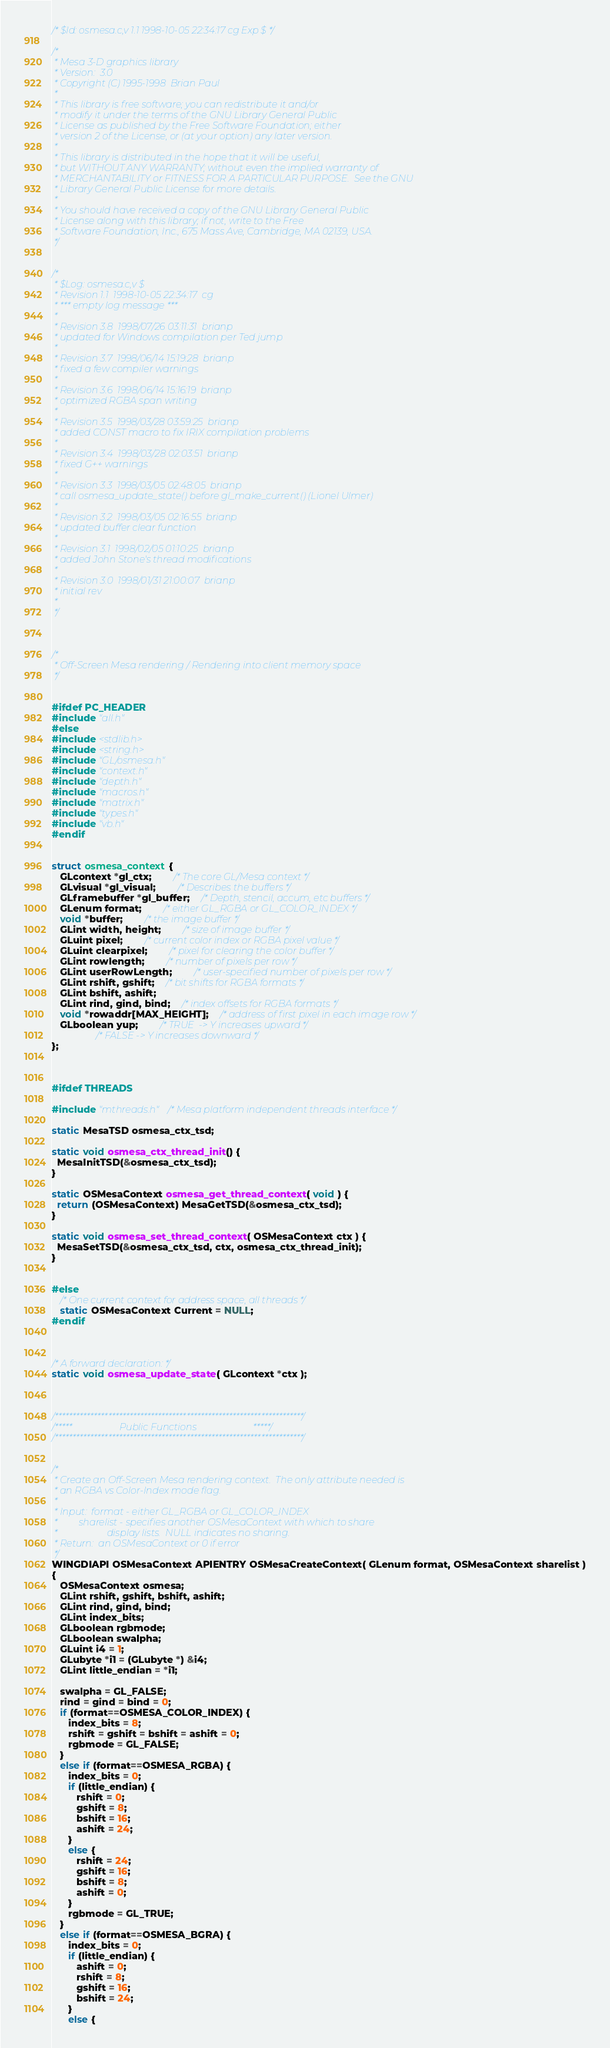<code> <loc_0><loc_0><loc_500><loc_500><_C_>/* $Id: osmesa.c,v 1.1 1998-10-05 22:34:17 cg Exp $ */

/*
 * Mesa 3-D graphics library
 * Version:  3.0
 * Copyright (C) 1995-1998  Brian Paul
 *
 * This library is free software; you can redistribute it and/or
 * modify it under the terms of the GNU Library General Public
 * License as published by the Free Software Foundation; either
 * version 2 of the License, or (at your option) any later version.
 *
 * This library is distributed in the hope that it will be useful,
 * but WITHOUT ANY WARRANTY; without even the implied warranty of
 * MERCHANTABILITY or FITNESS FOR A PARTICULAR PURPOSE.  See the GNU
 * Library General Public License for more details.
 *
 * You should have received a copy of the GNU Library General Public
 * License along with this library; if not, write to the Free
 * Software Foundation, Inc., 675 Mass Ave, Cambridge, MA 02139, USA.
 */


/*
 * $Log: osmesa.c,v $
 * Revision 1.1  1998-10-05 22:34:17  cg
 * *** empty log message ***
 *
 * Revision 3.8  1998/07/26 03:11:31  brianp
 * updated for Windows compilation per Ted jump
 *
 * Revision 3.7  1998/06/14 15:19:28  brianp
 * fixed a few compiler warnings
 *
 * Revision 3.6  1998/06/14 15:16:19  brianp
 * optimized RGBA span writing
 *
 * Revision 3.5  1998/03/28 03:59:25  brianp
 * added CONST macro to fix IRIX compilation problems
 *
 * Revision 3.4  1998/03/28 02:03:51  brianp
 * fixed G++ warnings
 *
 * Revision 3.3  1998/03/05 02:48:05  brianp
 * call osmesa_update_state() before gl_make_current() (Lionel Ulmer)
 *
 * Revision 3.2  1998/03/05 02:16:55  brianp
 * updated buffer clear function
 *
 * Revision 3.1  1998/02/05 01:10:25  brianp
 * added John Stone's thread modifications
 *
 * Revision 3.0  1998/01/31 21:00:07  brianp
 * initial rev
 *
 */



/*
 * Off-Screen Mesa rendering / Rendering into client memory space
 */


#ifdef PC_HEADER
#include "all.h"
#else
#include <stdlib.h>
#include <string.h>
#include "GL/osmesa.h"
#include "context.h"
#include "depth.h"
#include "macros.h"
#include "matrix.h"
#include "types.h"
#include "vb.h"
#endif


struct osmesa_context {
   GLcontext *gl_ctx;		/* The core GL/Mesa context */
   GLvisual *gl_visual;		/* Describes the buffers */
   GLframebuffer *gl_buffer;	/* Depth, stencil, accum, etc buffers */
   GLenum format;		/* either GL_RGBA or GL_COLOR_INDEX */
   void *buffer;		/* the image buffer */
   GLint width, height;		/* size of image buffer */
   GLuint pixel;		/* current color index or RGBA pixel value */
   GLuint clearpixel;		/* pixel for clearing the color buffer */
   GLint rowlength;		/* number of pixels per row */
   GLint userRowLength;		/* user-specified number of pixels per row */
   GLint rshift, gshift;	/* bit shifts for RGBA formats */
   GLint bshift, ashift;
   GLint rind, gind, bind;	/* index offsets for RGBA formats */
   void *rowaddr[MAX_HEIGHT];	/* address of first pixel in each image row */
   GLboolean yup;		/* TRUE  -> Y increases upward */
				/* FALSE -> Y increases downward */
};



#ifdef THREADS

#include "mthreads.h" /* Mesa platform independent threads interface */

static MesaTSD osmesa_ctx_tsd;

static void osmesa_ctx_thread_init() {
  MesaInitTSD(&osmesa_ctx_tsd);
}

static OSMesaContext osmesa_get_thread_context( void ) {
  return (OSMesaContext) MesaGetTSD(&osmesa_ctx_tsd);
}

static void osmesa_set_thread_context( OSMesaContext ctx ) {
  MesaSetTSD(&osmesa_ctx_tsd, ctx, osmesa_ctx_thread_init);
}


#else
   /* One current context for address space, all threads */
   static OSMesaContext Current = NULL;
#endif



/* A forward declaration: */
static void osmesa_update_state( GLcontext *ctx );



/**********************************************************************/
/*****                    Public Functions                        *****/
/**********************************************************************/


/*
 * Create an Off-Screen Mesa rendering context.  The only attribute needed is
 * an RGBA vs Color-Index mode flag.
 *
 * Input:  format - either GL_RGBA or GL_COLOR_INDEX
 *         sharelist - specifies another OSMesaContext with which to share
 *                     display lists.  NULL indicates no sharing.
 * Return:  an OSMesaContext or 0 if error
 */
WINGDIAPI OSMesaContext APIENTRY OSMesaCreateContext( GLenum format, OSMesaContext sharelist )
{
   OSMesaContext osmesa;
   GLint rshift, gshift, bshift, ashift;
   GLint rind, gind, bind;
   GLint index_bits;
   GLboolean rgbmode;
   GLboolean swalpha;
   GLuint i4 = 1;
   GLubyte *i1 = (GLubyte *) &i4;
   GLint little_endian = *i1;

   swalpha = GL_FALSE;
   rind = gind = bind = 0;
   if (format==OSMESA_COLOR_INDEX) {
      index_bits = 8;
      rshift = gshift = bshift = ashift = 0;
      rgbmode = GL_FALSE;
   }
   else if (format==OSMESA_RGBA) {
      index_bits = 0;
      if (little_endian) {
         rshift = 0;
         gshift = 8;
         bshift = 16;
         ashift = 24;
      }
      else {
         rshift = 24;
         gshift = 16;
         bshift = 8;
         ashift = 0;
      }
      rgbmode = GL_TRUE;
   }
   else if (format==OSMESA_BGRA) {
      index_bits = 0;
      if (little_endian) {
         ashift = 0;
         rshift = 8;
         gshift = 16;
         bshift = 24;
      }
      else {</code> 